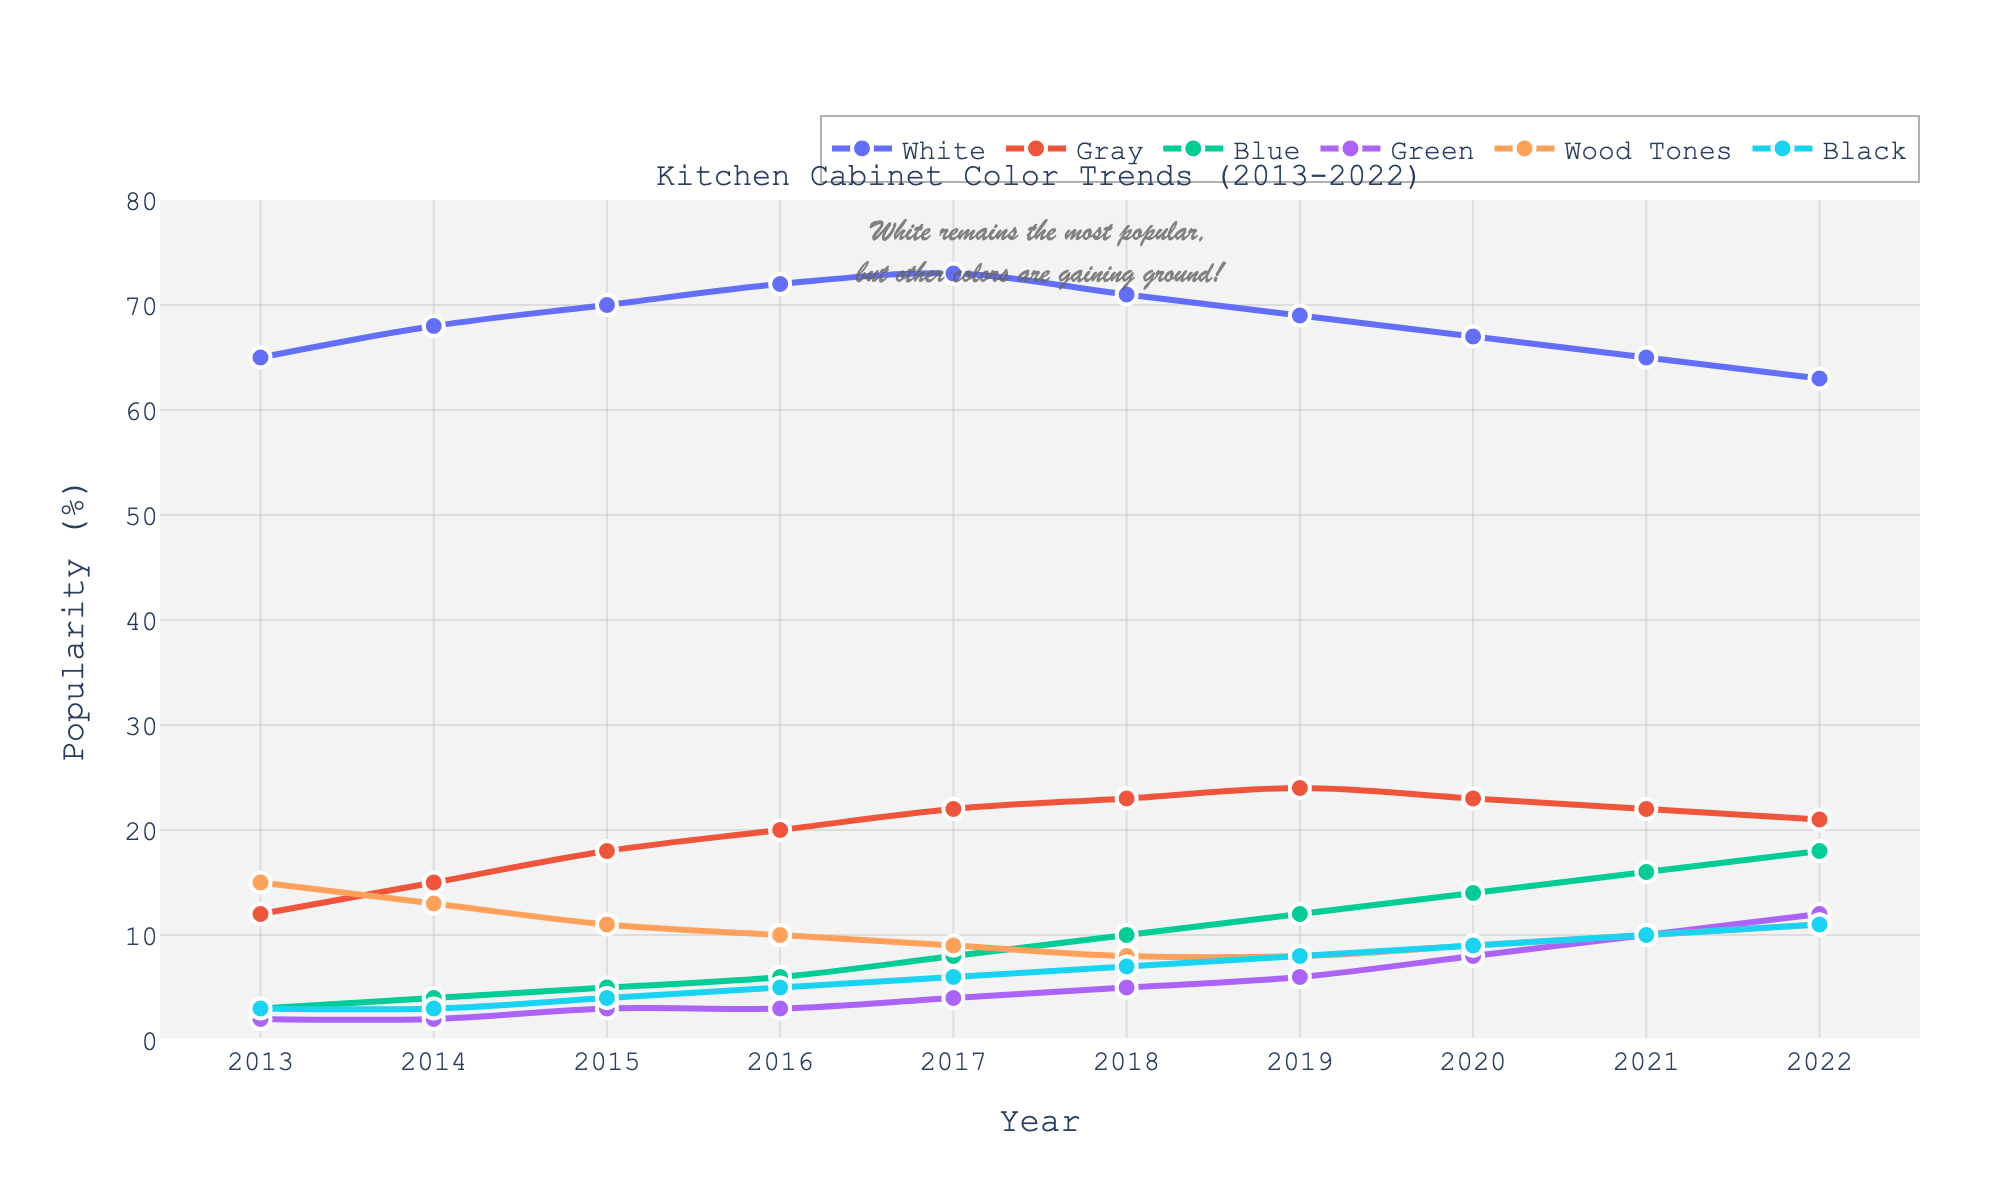What was the most popular color in 2015? The figure shows the trends in color popularity over the past decade. According to the figure, the popularity of white cabinets in 2015 was the highest relative to other colors.
Answer: White Which color shows a consistent increase in popularity from 2013 to 2022? To determine the color with a consistent increase, we need to analyze the trend lines for each color over the given years. Gray shows a steady rise in popularity from 2013 to 2022.
Answer: Gray In what year did the popularity of Black cabinets surpass 5%? By inspecting the plotted lines, we can observe that Black cabinets' popularity exceeded 5% starting in 2017.
Answer: 2017 Which year had the smallest popularity difference between Blue and Green cabinets? To find the smallest difference, we need to subtract the popularity percentages of Blue and Green for each year and compare them. In 2014, the difference is 4% − 2% = 2%, which is the smallest.
Answer: 2014 How did the popularity of Green cabinets change from 2018 to 2020? We can see from the graph that Green cabinets' popularity increased from 5% in 2018 to 8% in 2020, indicating an upward trend.
Answer: Increased Which color had a decline in popularity between 2017 and 2018? By visually inspecting the graph, the White cabinets’ popularity decreased from 73% in 2017 to 71% in 2018.
Answer: White What is the average popularity of Wood Tones cabinets over the decade? The values for Wood Tones are 15, 13, 11, 10, 9, 8, 8, 9, 10, 11. Adding these gives 104, and dividing by 10 (the number of years) gives an average of 10.4%.
Answer: 10.4% By how much did the popularity of Gray cabinets change from 2013 to 2022? In 2013, Gray had a popularity of 12%, and in 2022, it was 21%. The change is 21% − 12% = 9%.
Answer: 9% In which year did the sum of the popularities of Blue and Black cabinets equal the popularity of White cabinets? Examining the graph year by year, in 2022, Blue (18%) + Black (11%) = 29%, and White is 63% which is not equal. On re-evaluation, no year aligns exactly since White consistently remained more popular.
Answer: None Which color had the highest percentage increase from 2013 to 2022? We need to calculate the percentage increase for each color. The formula is (Popularity in 2022 − Popularity in 2013) / Popularity in 2013 * 100%. Black had the highest increase from 3% to 11%, which is ((11-3)/3)*100% = 266.67%.
Answer: Black 